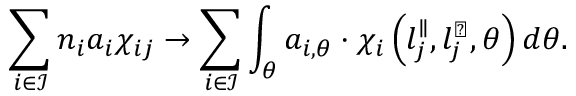<formula> <loc_0><loc_0><loc_500><loc_500>\sum _ { i \in \mathcal { I } } { n _ { i } a _ { i } \chi _ { i j } } \rightarrow \sum _ { i \in \mathcal { I } } \int _ { \theta } { a _ { i , \theta } \cdot \chi _ { i } \left ( l _ { j } ^ { \| } , l _ { j } ^ { \perp } , \theta \right ) d \theta } .</formula> 